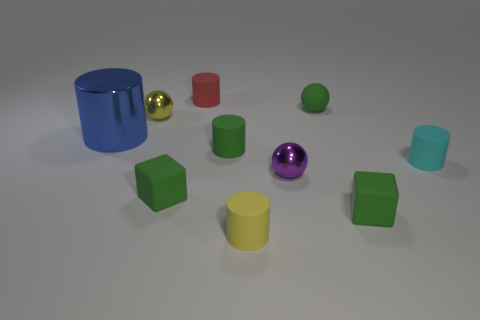Subtract all metallic balls. How many balls are left? 1 Subtract 2 cylinders. How many cylinders are left? 3 Subtract all yellow cylinders. How many cylinders are left? 4 Subtract all blocks. How many objects are left? 8 Subtract all gray cylinders. Subtract all blue balls. How many cylinders are left? 5 Subtract all small metal spheres. Subtract all tiny yellow rubber cylinders. How many objects are left? 7 Add 5 cyan rubber cylinders. How many cyan rubber cylinders are left? 6 Add 3 red objects. How many red objects exist? 4 Subtract 1 yellow cylinders. How many objects are left? 9 